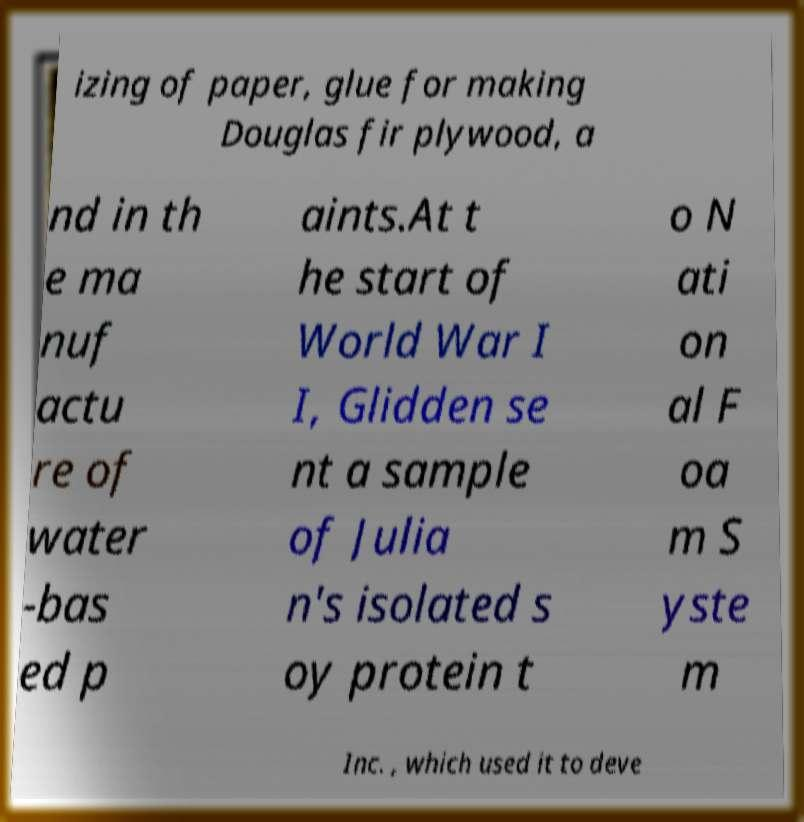What messages or text are displayed in this image? I need them in a readable, typed format. izing of paper, glue for making Douglas fir plywood, a nd in th e ma nuf actu re of water -bas ed p aints.At t he start of World War I I, Glidden se nt a sample of Julia n's isolated s oy protein t o N ati on al F oa m S yste m Inc. , which used it to deve 